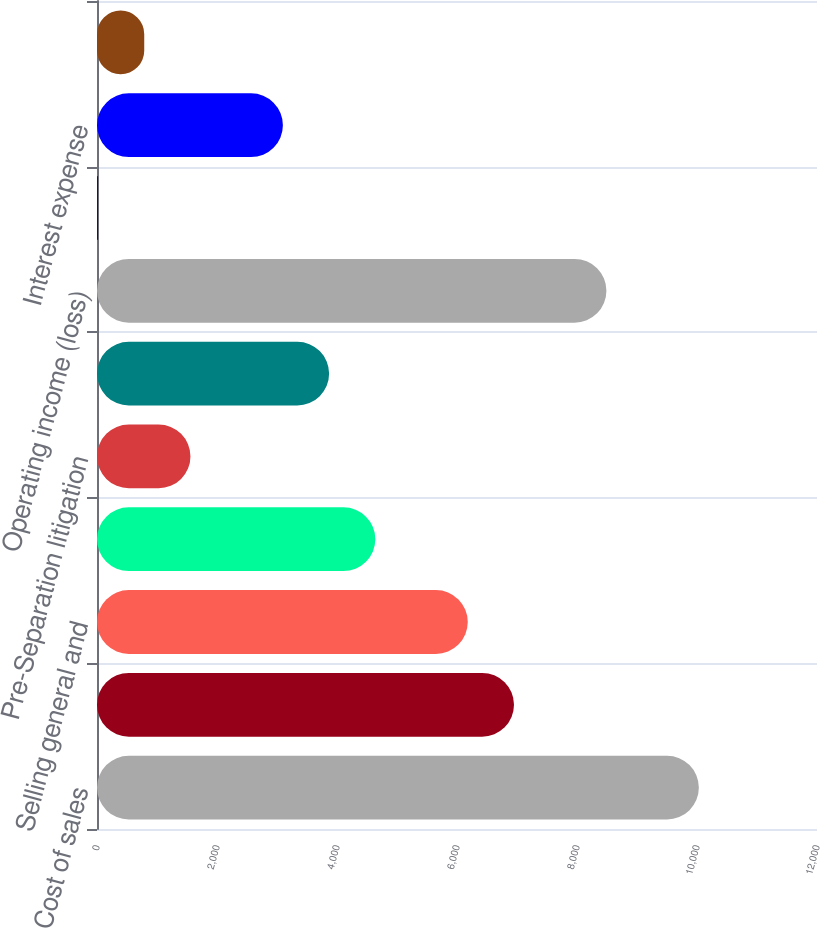Convert chart. <chart><loc_0><loc_0><loc_500><loc_500><bar_chart><fcel>Cost of sales<fcel>Gross income<fcel>Selling general and<fcel>Research development and<fcel>Pre-Separation litigation<fcel>Restructuring and other<fcel>Operating income (loss)<fcel>Interest income<fcel>Interest expense<fcel>Other income (expense) net<nl><fcel>10030.9<fcel>6949.7<fcel>6179.4<fcel>4638.8<fcel>1557.6<fcel>3868.5<fcel>8490.3<fcel>17<fcel>3098.2<fcel>787.3<nl></chart> 